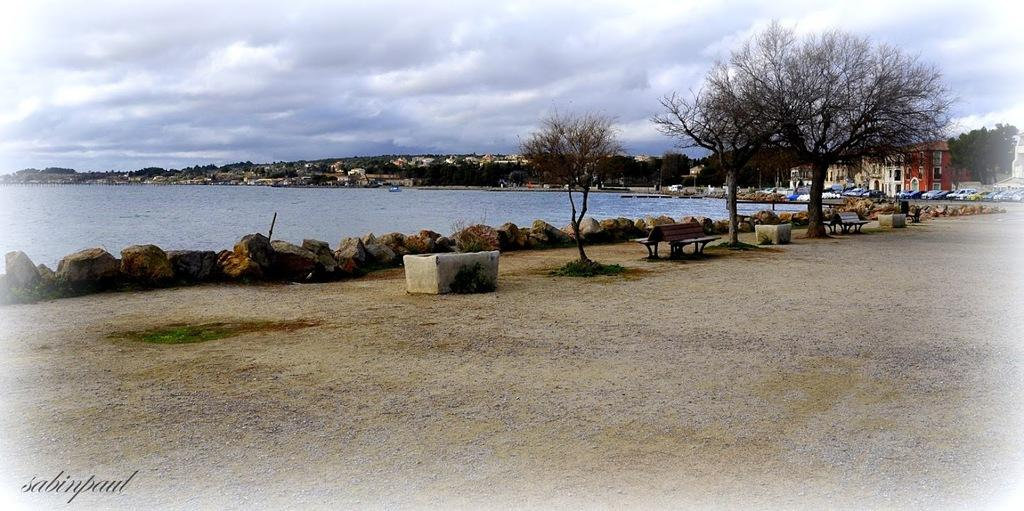What type of seating is present in the image? There are benches in the image. What type of vegetation is present in the image? There are trees in the image. What type of structures are present in the image? There are buildings in the image. What natural element is visible in the image? Water is visible in the image. What is visible at the top of the image? The sky is visible at the top of the image. Can you tell me how many giraffes are standing near the water in the image? There are no giraffes present in the image. What type of control system is used to manage the water in the image? There is no information about a control system in the image. 